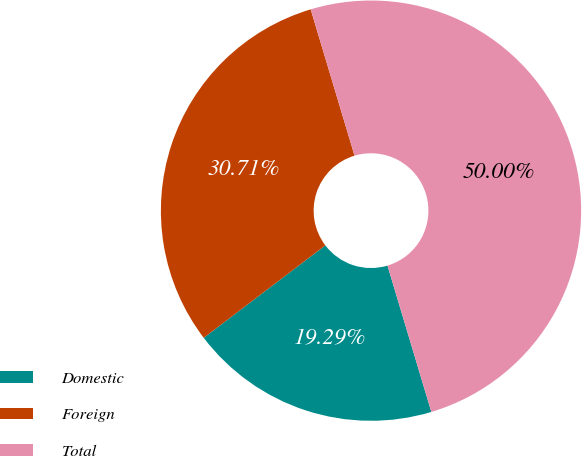Convert chart. <chart><loc_0><loc_0><loc_500><loc_500><pie_chart><fcel>Domestic<fcel>Foreign<fcel>Total<nl><fcel>19.29%<fcel>30.71%<fcel>50.0%<nl></chart> 